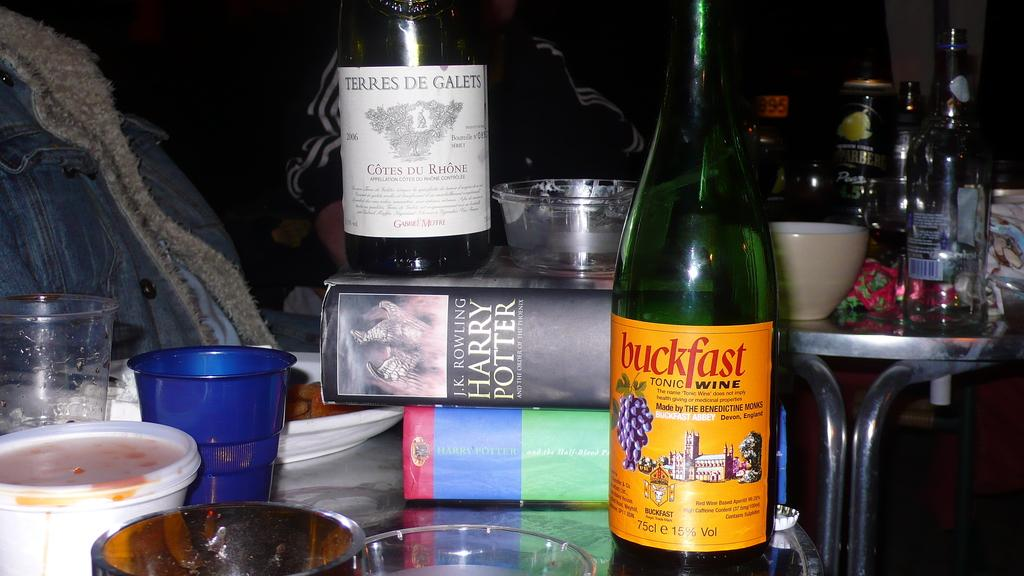<image>
Relay a brief, clear account of the picture shown. Two Harry Potter books on a table with bottles of wine. 